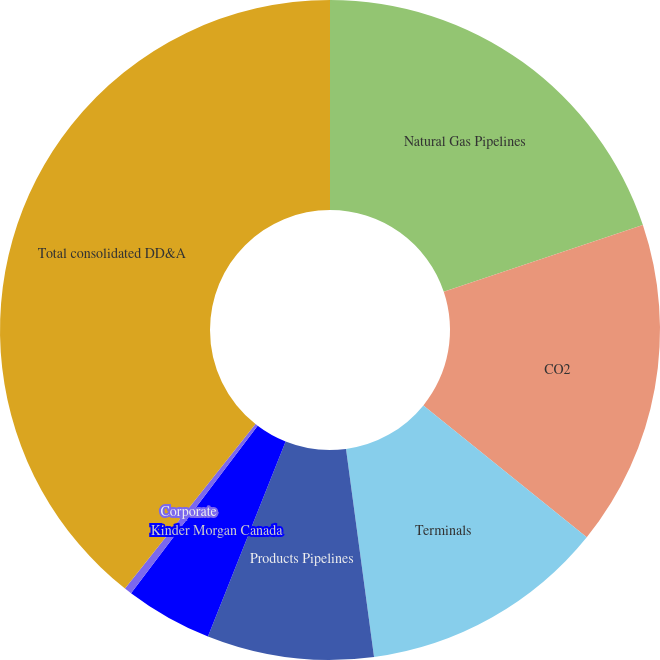<chart> <loc_0><loc_0><loc_500><loc_500><pie_chart><fcel>Natural Gas Pipelines<fcel>CO2<fcel>Terminals<fcel>Products Pipelines<fcel>Kinder Morgan Canada<fcel>Corporate<fcel>Total consolidated DD&A<nl><fcel>19.85%<fcel>15.96%<fcel>12.06%<fcel>8.16%<fcel>4.27%<fcel>0.37%<fcel>39.33%<nl></chart> 